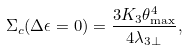<formula> <loc_0><loc_0><loc_500><loc_500>\Sigma _ { c } ( \Delta \epsilon = 0 ) = \frac { 3 K _ { 3 } \theta _ { \max } ^ { 4 } } { 4 \lambda _ { 3 \perp } } ,</formula> 